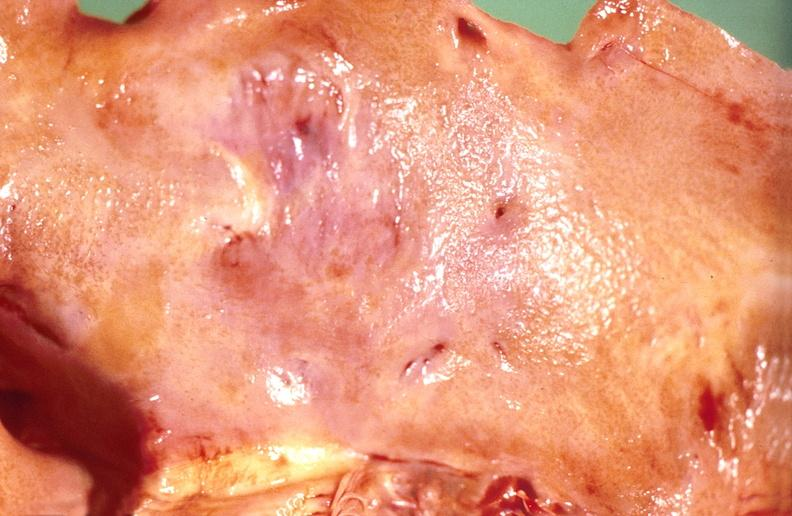where is this?
Answer the question using a single word or phrase. Heart 